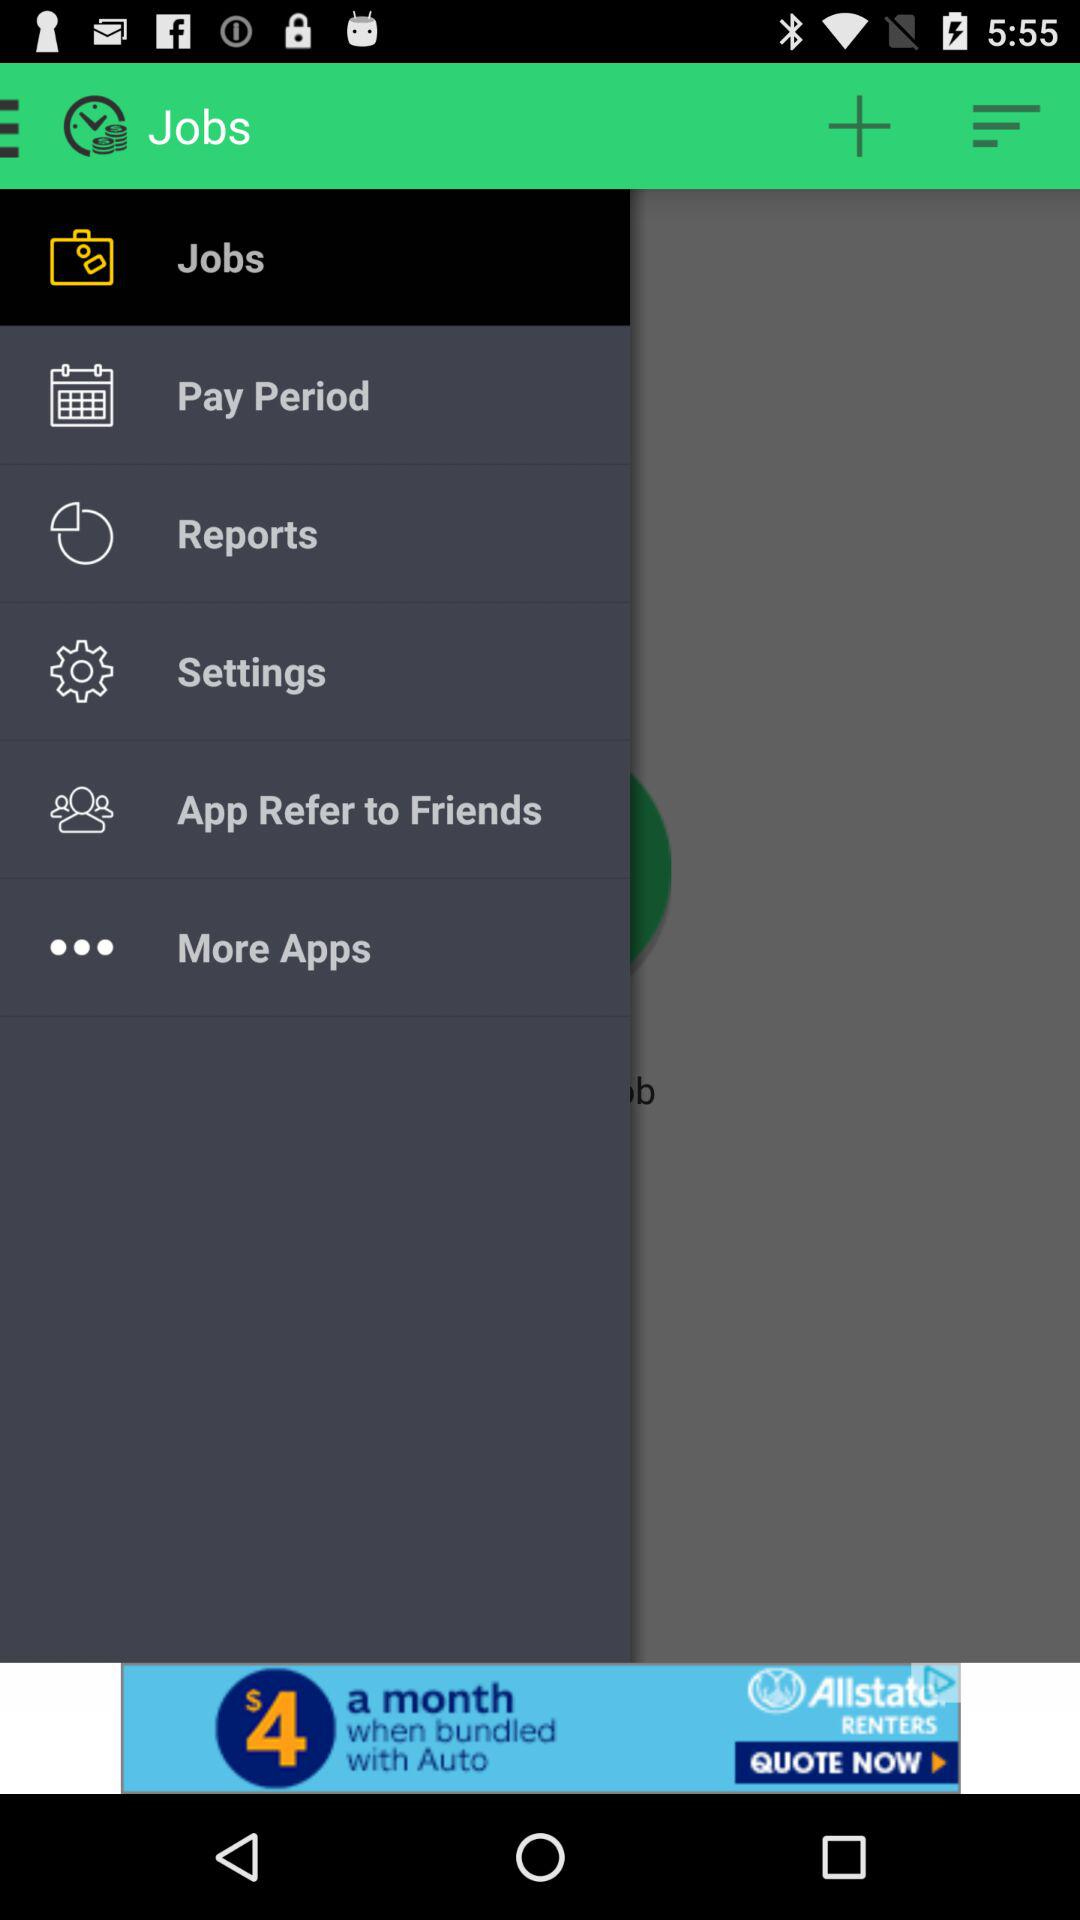How many items are in the menu?
Answer the question using a single word or phrase. 6 